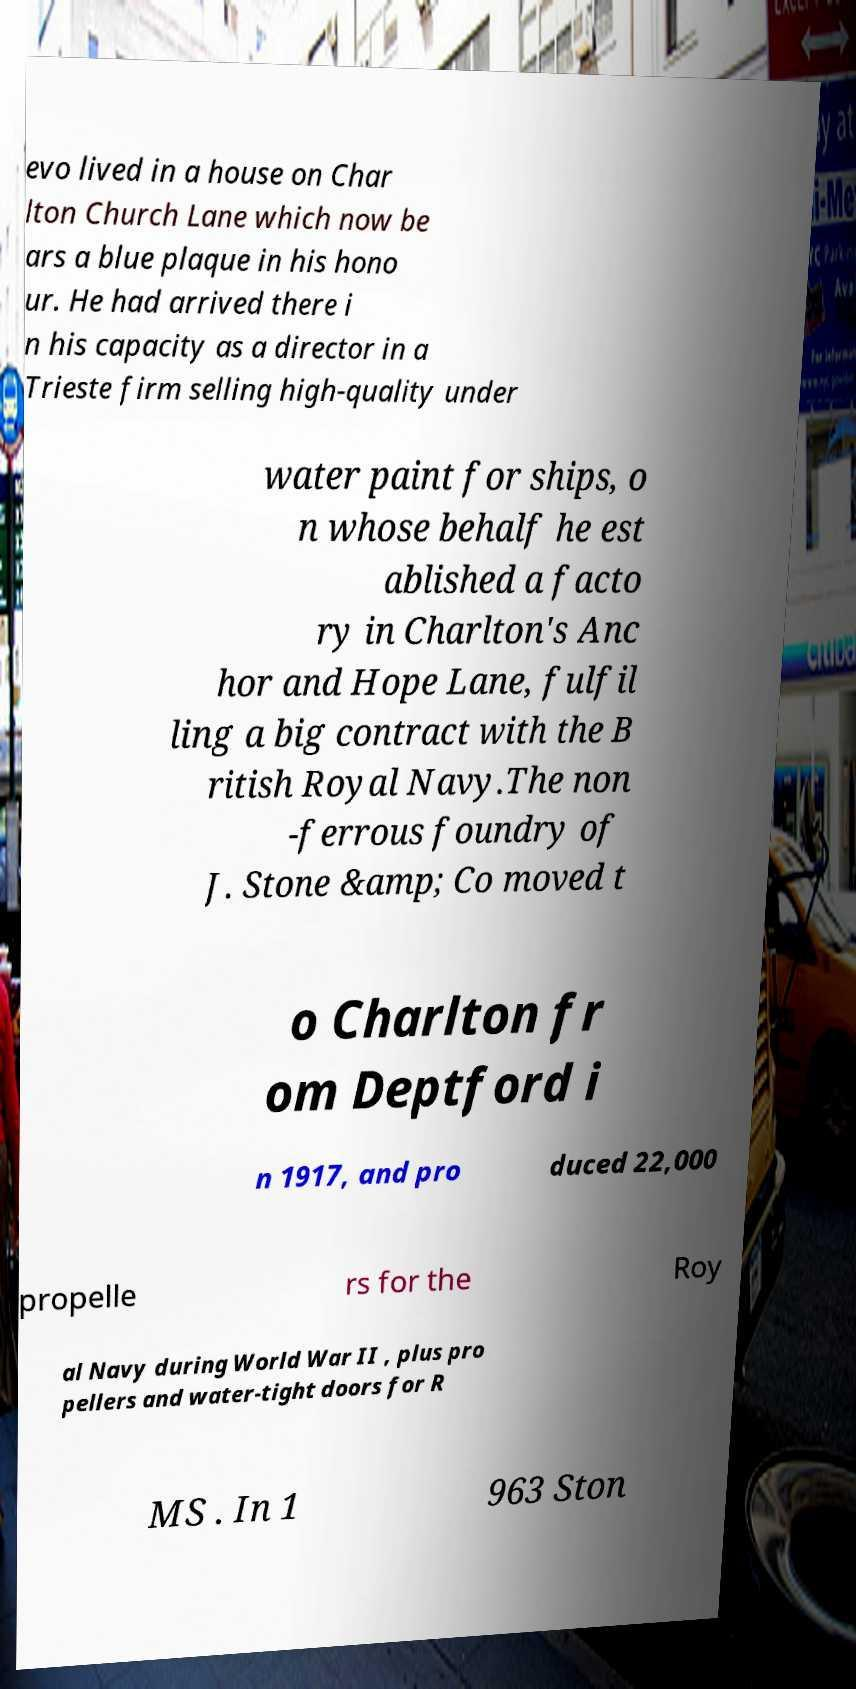For documentation purposes, I need the text within this image transcribed. Could you provide that? evo lived in a house on Char lton Church Lane which now be ars a blue plaque in his hono ur. He had arrived there i n his capacity as a director in a Trieste firm selling high-quality under water paint for ships, o n whose behalf he est ablished a facto ry in Charlton's Anc hor and Hope Lane, fulfil ling a big contract with the B ritish Royal Navy.The non -ferrous foundry of J. Stone &amp; Co moved t o Charlton fr om Deptford i n 1917, and pro duced 22,000 propelle rs for the Roy al Navy during World War II , plus pro pellers and water-tight doors for R MS . In 1 963 Ston 